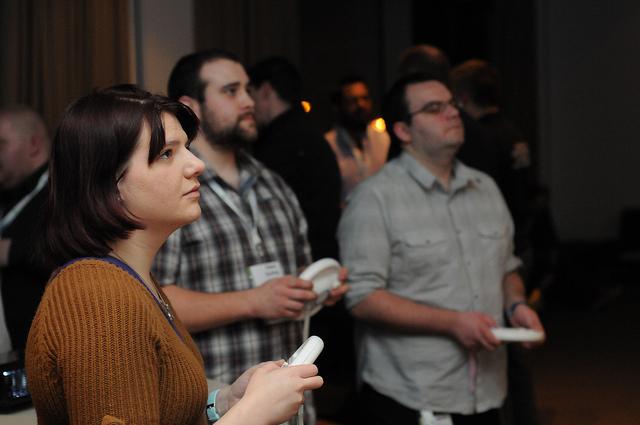Are the two guys sharing a hot dog?
Give a very brief answer. No. Is this picture in the United States?
Short answer required. Yes. Who is wearing a white lanyard?
Answer briefly. Man in middle. Who is wearing glasses?
Answer briefly. Man. What pattern shirt is the man wearing?
Concise answer only. Plaid. Which woman is wearing nail polish?
Keep it brief. None. What are the people holding?
Short answer required. Controllers. Are they playing a game?
Answer briefly. Yes. Is anyone in the photo wearing flannel?
Short answer required. Yes. Have the men started eating?
Concise answer only. No. Do the players have a free hand?
Answer briefly. No. What color is the man's shirt in the background?
Be succinct. Black. Are these people excited?
Concise answer only. No. 